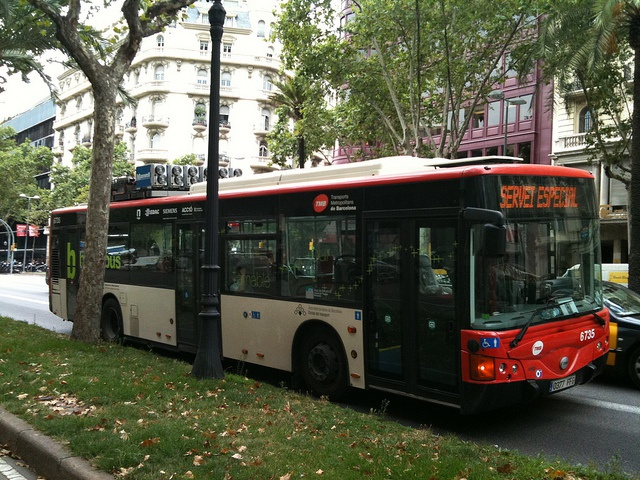Describe the objects in this image and their specific colors. I can see bus in darkgreen, black, gray, brown, and white tones, car in darkgreen, black, gray, and maroon tones, people in darkgreen, black, and gray tones, and people in darkgreen, black, and teal tones in this image. 